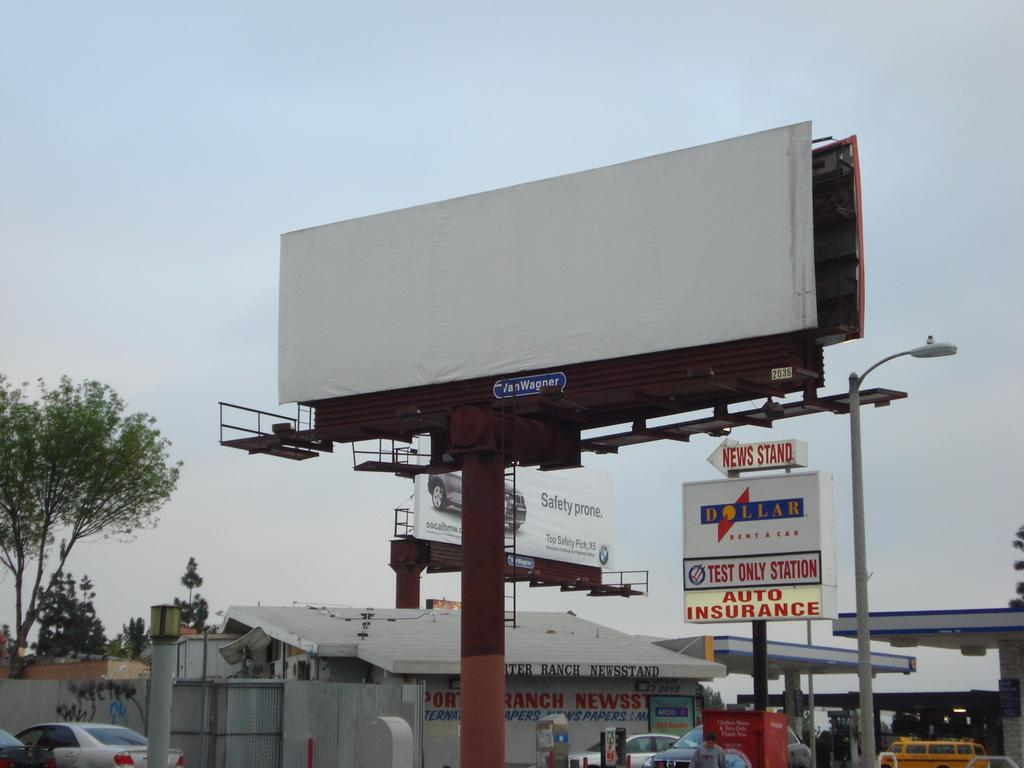<image>
Relay a brief, clear account of the picture shown. Empty Billboard sign with a dollar car rental store sign that says Newstand and Auto Insurance. 